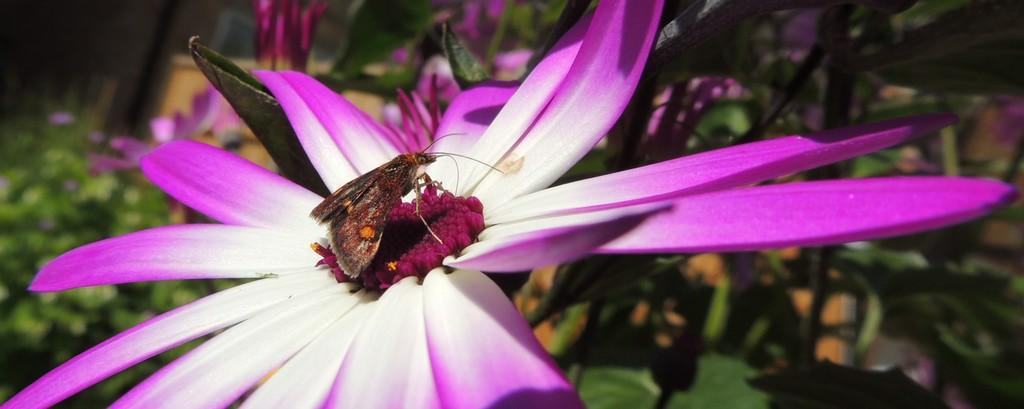What is the main subject of the image? There is a butterfly in the image. Where is the butterfly located? The butterfly is on a pink and white flower. What can be seen in the background of the image? There are plants visible in the background of the image. What word does the butterfly write in the image? Butterflies do not have the ability to write words, so there is no word written by the butterfly in the image. 